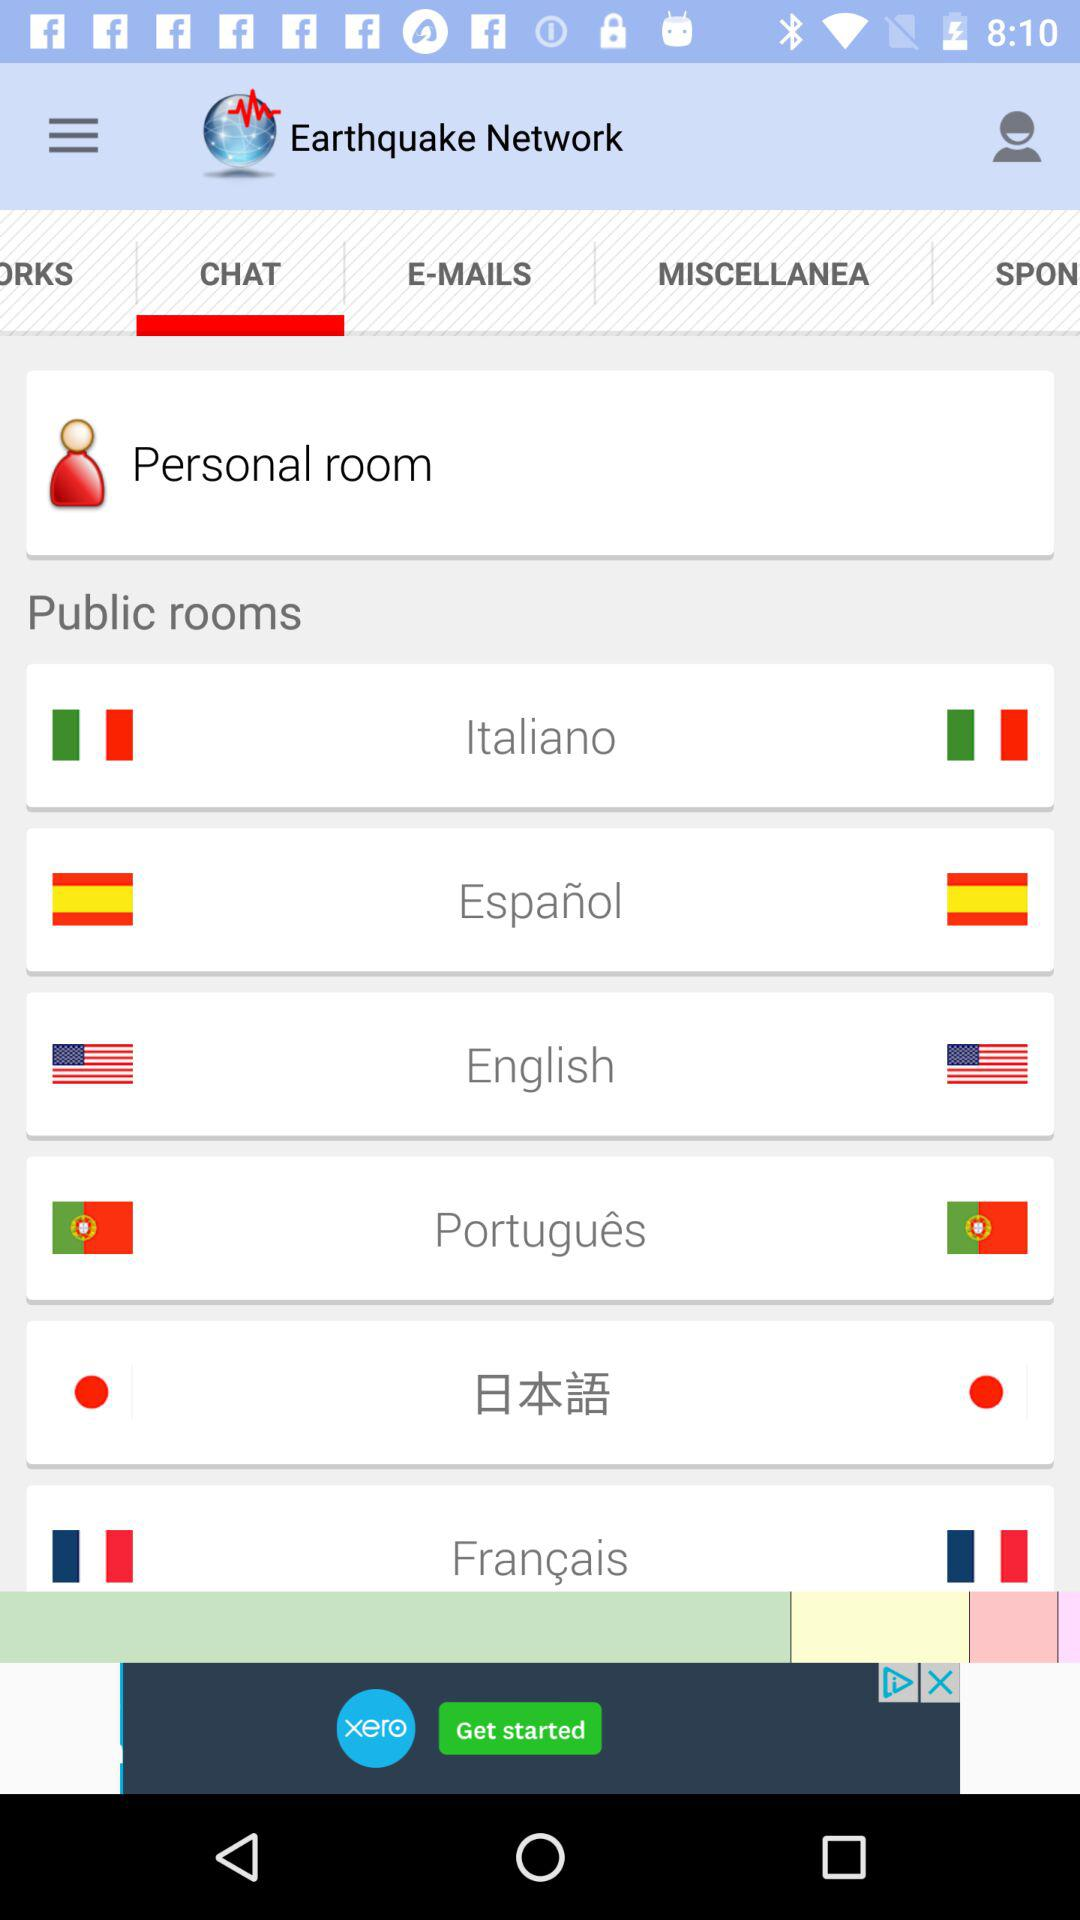What is the selected tab? The selected tab is "CHAT". 